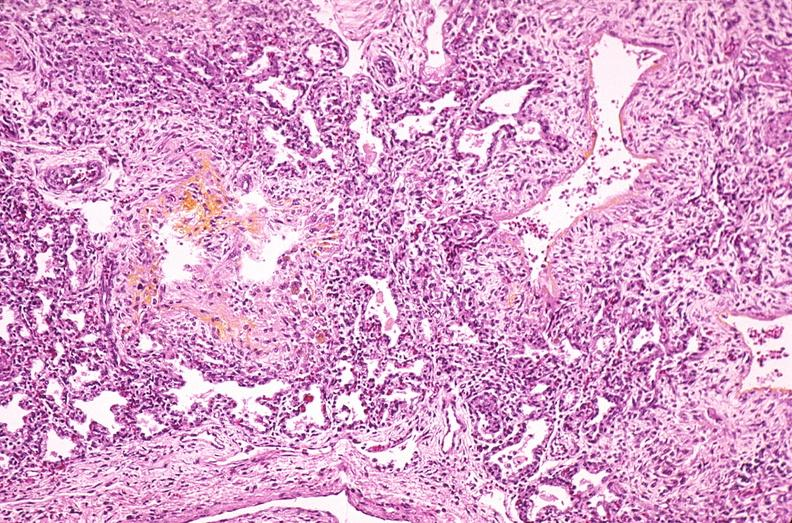s lymphangiomatosis generalized present?
Answer the question using a single word or phrase. No 